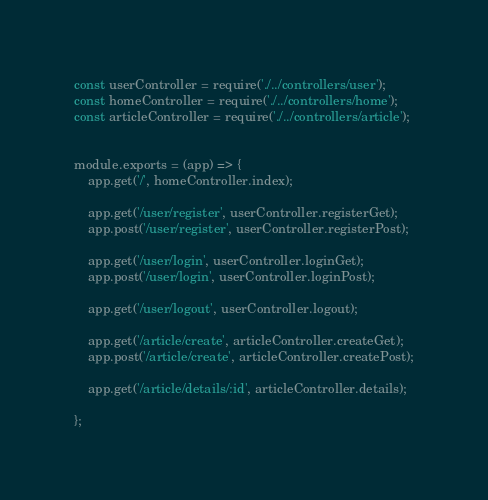Convert code to text. <code><loc_0><loc_0><loc_500><loc_500><_JavaScript_>const userController = require('./../controllers/user');
const homeController = require('./../controllers/home');
const articleController = require('./../controllers/article');


module.exports = (app) => {
    app.get('/', homeController.index);

    app.get('/user/register', userController.registerGet);
    app.post('/user/register', userController.registerPost);

    app.get('/user/login', userController.loginGet);
    app.post('/user/login', userController.loginPost);

    app.get('/user/logout', userController.logout);

    app.get('/article/create', articleController.createGet);
    app.post('/article/create', articleController.createPost);

    app.get('/article/details/:id', articleController.details);

};

</code> 